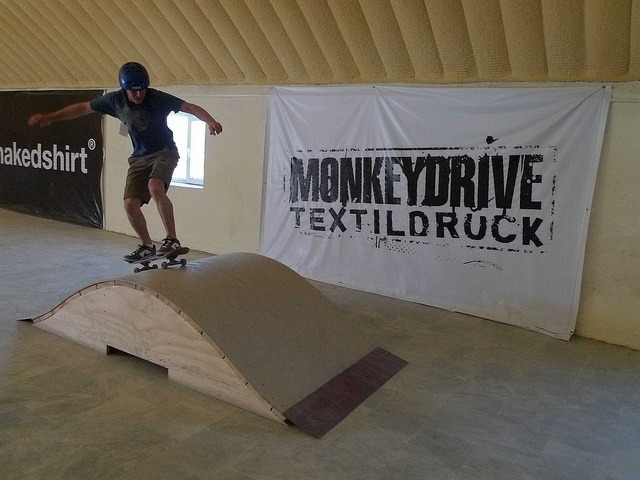Describe the objects in this image and their specific colors. I can see people in olive, black, maroon, gray, and darkgray tones and skateboard in olive, black, and gray tones in this image. 